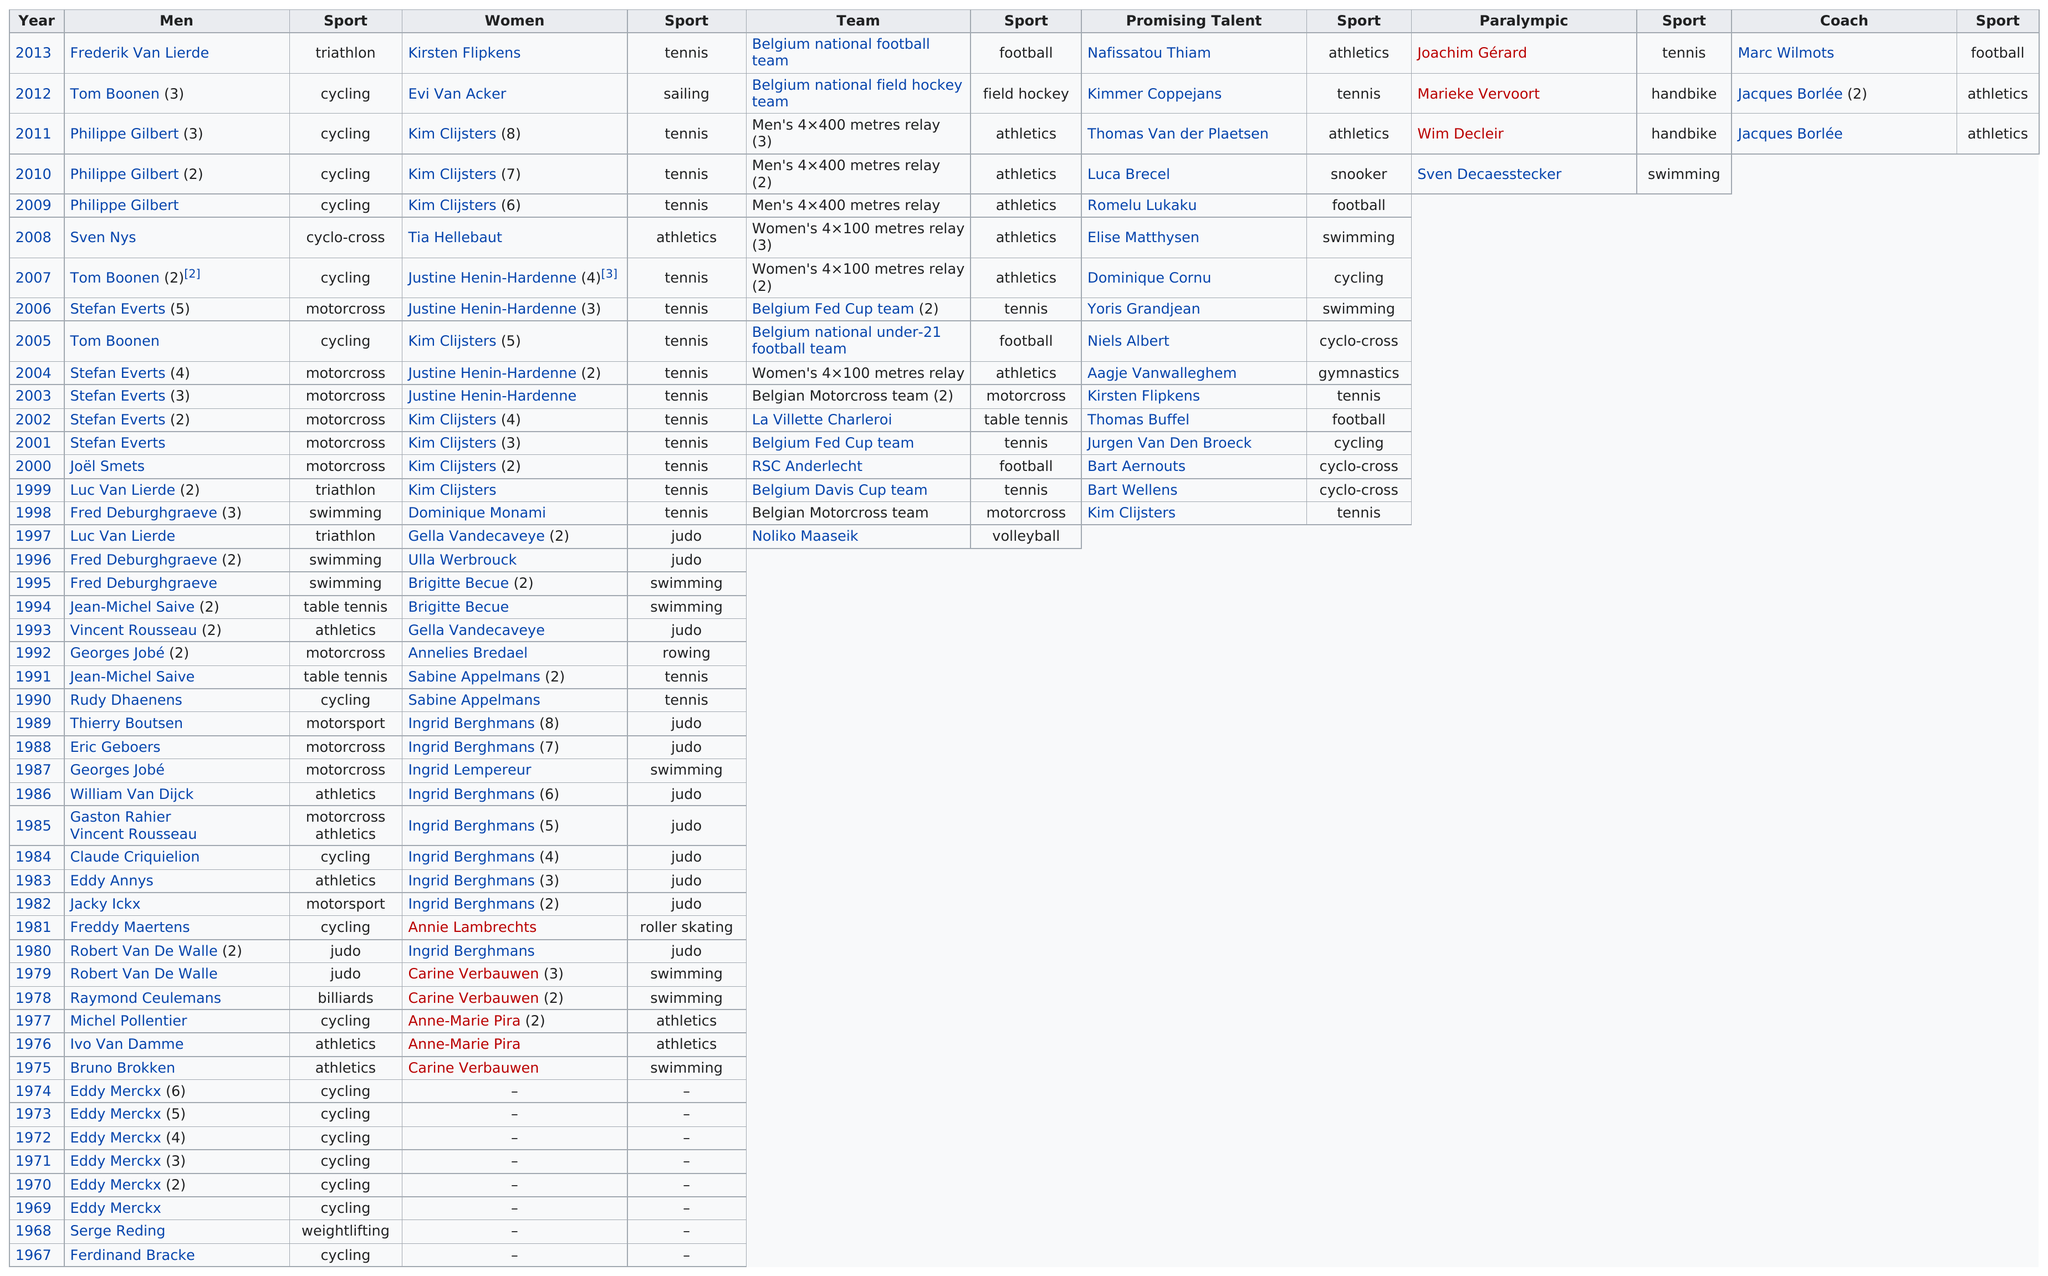Draw attention to some important aspects in this diagram. The number of cyclists who have won sportsman of the year is 17, while the number of billiards players who have won is unknown. The most recent Belgian Coach of the Year award was won by the coach for football. The winner of the Belgian Sportsman of the Year award the most times is Eddy Merckx, who has won it two times. Joachim Gerard was preceded by Marieke Vervoort as the winner of the Paralympic category. Jacques Borlée was the first person to win in the coach category. 